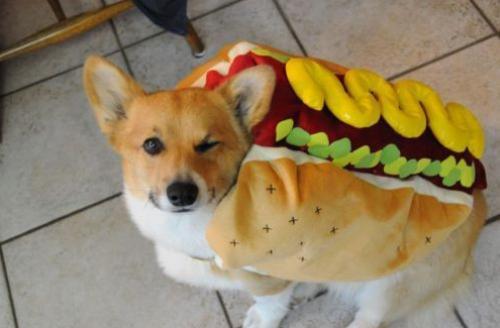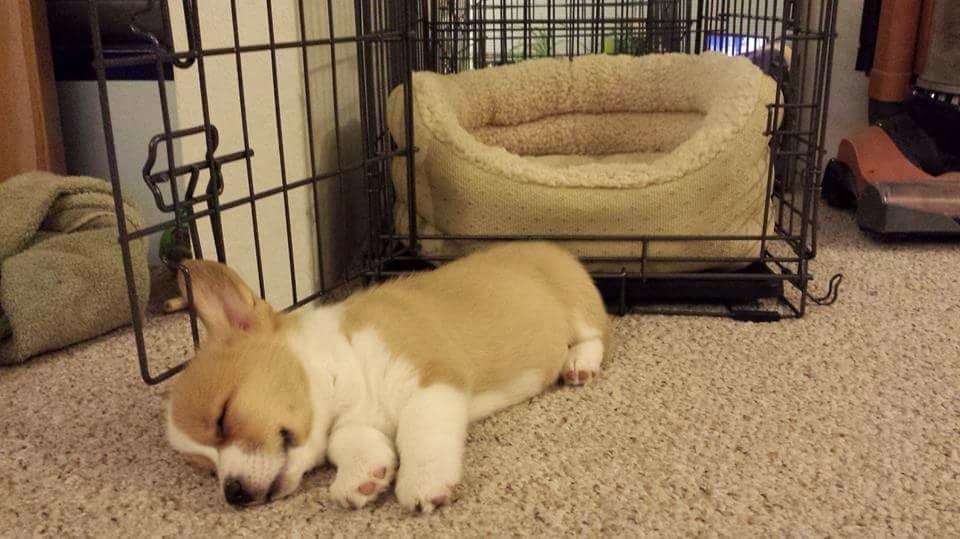The first image is the image on the left, the second image is the image on the right. For the images displayed, is the sentence "There is at most 1 young Corgi laying on it right side, sleeping." factually correct? Answer yes or no. Yes. 